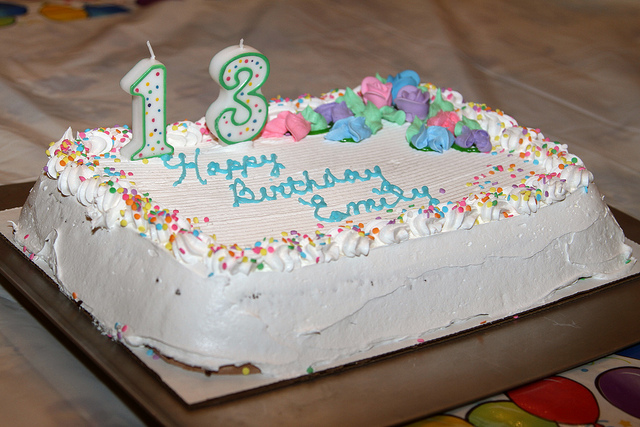<image>What type of vehicle is on the cake? There is no vehicle on the cake. What type of vehicle is on the cake? There is no vehicle on the cake. 